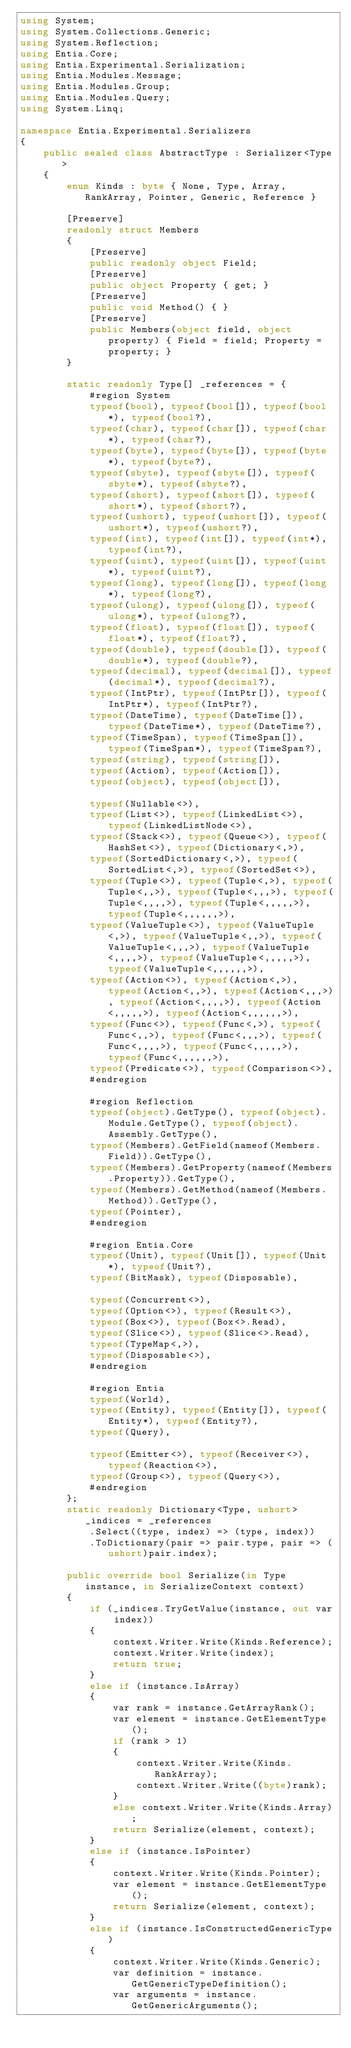<code> <loc_0><loc_0><loc_500><loc_500><_C#_>using System;
using System.Collections.Generic;
using System.Reflection;
using Entia.Core;
using Entia.Experimental.Serialization;
using Entia.Modules.Message;
using Entia.Modules.Group;
using Entia.Modules.Query;
using System.Linq;

namespace Entia.Experimental.Serializers
{
    public sealed class AbstractType : Serializer<Type>
    {
        enum Kinds : byte { None, Type, Array, RankArray, Pointer, Generic, Reference }

        [Preserve]
        readonly struct Members
        {
            [Preserve]
            public readonly object Field;
            [Preserve]
            public object Property { get; }
            [Preserve]
            public void Method() { }
            [Preserve]
            public Members(object field, object property) { Field = field; Property = property; }
        }

        static readonly Type[] _references = {
            #region System
            typeof(bool), typeof(bool[]), typeof(bool*), typeof(bool?),
            typeof(char), typeof(char[]), typeof(char*), typeof(char?),
            typeof(byte), typeof(byte[]), typeof(byte*), typeof(byte?),
            typeof(sbyte), typeof(sbyte[]), typeof(sbyte*), typeof(sbyte?),
            typeof(short), typeof(short[]), typeof(short*), typeof(short?),
            typeof(ushort), typeof(ushort[]), typeof(ushort*), typeof(ushort?),
            typeof(int), typeof(int[]), typeof(int*), typeof(int?),
            typeof(uint), typeof(uint[]), typeof(uint*), typeof(uint?),
            typeof(long), typeof(long[]), typeof(long*), typeof(long?),
            typeof(ulong), typeof(ulong[]), typeof(ulong*), typeof(ulong?),
            typeof(float), typeof(float[]), typeof(float*), typeof(float?),
            typeof(double), typeof(double[]), typeof(double*), typeof(double?),
            typeof(decimal), typeof(decimal[]), typeof(decimal*), typeof(decimal?),
            typeof(IntPtr), typeof(IntPtr[]), typeof(IntPtr*), typeof(IntPtr?),
            typeof(DateTime), typeof(DateTime[]), typeof(DateTime*), typeof(DateTime?),
            typeof(TimeSpan), typeof(TimeSpan[]), typeof(TimeSpan*), typeof(TimeSpan?),
            typeof(string), typeof(string[]),
            typeof(Action), typeof(Action[]),
            typeof(object), typeof(object[]),

            typeof(Nullable<>),
            typeof(List<>), typeof(LinkedList<>), typeof(LinkedListNode<>),
            typeof(Stack<>), typeof(Queue<>), typeof(HashSet<>), typeof(Dictionary<,>),
            typeof(SortedDictionary<,>), typeof(SortedList<,>), typeof(SortedSet<>),
            typeof(Tuple<>), typeof(Tuple<,>), typeof(Tuple<,,>), typeof(Tuple<,,,>), typeof(Tuple<,,,,>), typeof(Tuple<,,,,,>), typeof(Tuple<,,,,,,>),
            typeof(ValueTuple<>), typeof(ValueTuple<,>), typeof(ValueTuple<,,>), typeof(ValueTuple<,,,>), typeof(ValueTuple<,,,,>), typeof(ValueTuple<,,,,,>), typeof(ValueTuple<,,,,,,>),
            typeof(Action<>), typeof(Action<,>), typeof(Action<,,>), typeof(Action<,,,>), typeof(Action<,,,,>), typeof(Action<,,,,,>), typeof(Action<,,,,,,>),
            typeof(Func<>), typeof(Func<,>), typeof(Func<,,>), typeof(Func<,,,>), typeof(Func<,,,,>), typeof(Func<,,,,,>), typeof(Func<,,,,,,>),
            typeof(Predicate<>), typeof(Comparison<>),
            #endregion

            #region Reflection
            typeof(object).GetType(), typeof(object).Module.GetType(), typeof(object).Assembly.GetType(),
            typeof(Members).GetField(nameof(Members.Field)).GetType(),
            typeof(Members).GetProperty(nameof(Members.Property)).GetType(),
            typeof(Members).GetMethod(nameof(Members.Method)).GetType(),
            typeof(Pointer),
            #endregion

            #region Entia.Core
            typeof(Unit), typeof(Unit[]), typeof(Unit*), typeof(Unit?),
            typeof(BitMask), typeof(Disposable),

            typeof(Concurrent<>),
            typeof(Option<>), typeof(Result<>),
            typeof(Box<>), typeof(Box<>.Read),
            typeof(Slice<>), typeof(Slice<>.Read),
            typeof(TypeMap<,>),
            typeof(Disposable<>),
            #endregion

            #region Entia
            typeof(World),
            typeof(Entity), typeof(Entity[]), typeof(Entity*), typeof(Entity?),
            typeof(Query),

            typeof(Emitter<>), typeof(Receiver<>), typeof(Reaction<>),
            typeof(Group<>), typeof(Query<>),
            #endregion
        };
        static readonly Dictionary<Type, ushort> _indices = _references
            .Select((type, index) => (type, index))
            .ToDictionary(pair => pair.type, pair => (ushort)pair.index);

        public override bool Serialize(in Type instance, in SerializeContext context)
        {
            if (_indices.TryGetValue(instance, out var index))
            {
                context.Writer.Write(Kinds.Reference);
                context.Writer.Write(index);
                return true;
            }
            else if (instance.IsArray)
            {
                var rank = instance.GetArrayRank();
                var element = instance.GetElementType();
                if (rank > 1)
                {
                    context.Writer.Write(Kinds.RankArray);
                    context.Writer.Write((byte)rank);
                }
                else context.Writer.Write(Kinds.Array);
                return Serialize(element, context);
            }
            else if (instance.IsPointer)
            {
                context.Writer.Write(Kinds.Pointer);
                var element = instance.GetElementType();
                return Serialize(element, context);
            }
            else if (instance.IsConstructedGenericType)
            {
                context.Writer.Write(Kinds.Generic);
                var definition = instance.GetGenericTypeDefinition();
                var arguments = instance.GetGenericArguments();</code> 